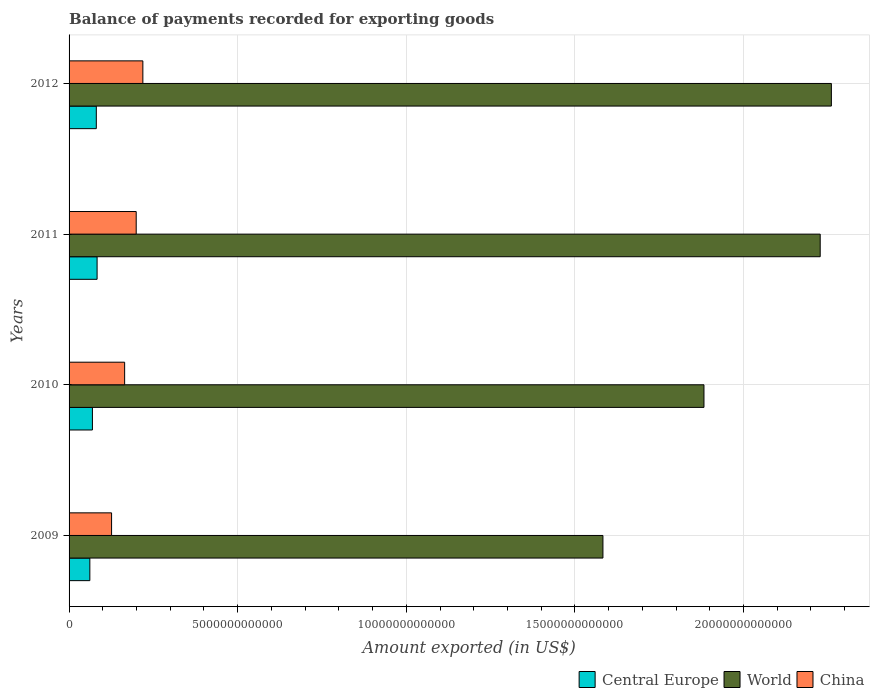Are the number of bars on each tick of the Y-axis equal?
Your response must be concise. Yes. What is the amount exported in Central Europe in 2012?
Provide a short and direct response. 8.08e+11. Across all years, what is the maximum amount exported in Central Europe?
Offer a terse response. 8.31e+11. Across all years, what is the minimum amount exported in China?
Give a very brief answer. 1.26e+12. In which year was the amount exported in Central Europe minimum?
Your response must be concise. 2009. What is the total amount exported in Central Europe in the graph?
Make the answer very short. 2.95e+12. What is the difference between the amount exported in Central Europe in 2010 and that in 2012?
Offer a very short reply. -1.15e+11. What is the difference between the amount exported in World in 2010 and the amount exported in Central Europe in 2009?
Make the answer very short. 1.82e+13. What is the average amount exported in China per year?
Keep it short and to the point. 1.77e+12. In the year 2009, what is the difference between the amount exported in China and amount exported in World?
Your response must be concise. -1.46e+13. In how many years, is the amount exported in Central Europe greater than 9000000000000 US$?
Your answer should be very brief. 0. What is the ratio of the amount exported in World in 2010 to that in 2011?
Provide a succinct answer. 0.85. Is the amount exported in Central Europe in 2011 less than that in 2012?
Provide a succinct answer. No. What is the difference between the highest and the second highest amount exported in Central Europe?
Ensure brevity in your answer.  2.29e+1. What is the difference between the highest and the lowest amount exported in World?
Keep it short and to the point. 6.77e+12. What does the 3rd bar from the top in 2009 represents?
Your answer should be compact. Central Europe. What does the 1st bar from the bottom in 2012 represents?
Make the answer very short. Central Europe. Are all the bars in the graph horizontal?
Your answer should be very brief. Yes. How many years are there in the graph?
Keep it short and to the point. 4. What is the difference between two consecutive major ticks on the X-axis?
Offer a terse response. 5.00e+12. Does the graph contain any zero values?
Your answer should be very brief. No. Where does the legend appear in the graph?
Give a very brief answer. Bottom right. What is the title of the graph?
Offer a terse response. Balance of payments recorded for exporting goods. Does "Kyrgyz Republic" appear as one of the legend labels in the graph?
Your answer should be very brief. No. What is the label or title of the X-axis?
Your response must be concise. Amount exported (in US$). What is the label or title of the Y-axis?
Give a very brief answer. Years. What is the Amount exported (in US$) in Central Europe in 2009?
Your response must be concise. 6.16e+11. What is the Amount exported (in US$) in World in 2009?
Your response must be concise. 1.58e+13. What is the Amount exported (in US$) of China in 2009?
Provide a short and direct response. 1.26e+12. What is the Amount exported (in US$) of Central Europe in 2010?
Ensure brevity in your answer.  6.92e+11. What is the Amount exported (in US$) of World in 2010?
Offer a terse response. 1.88e+13. What is the Amount exported (in US$) of China in 2010?
Keep it short and to the point. 1.65e+12. What is the Amount exported (in US$) in Central Europe in 2011?
Keep it short and to the point. 8.31e+11. What is the Amount exported (in US$) in World in 2011?
Your answer should be very brief. 2.23e+13. What is the Amount exported (in US$) in China in 2011?
Offer a terse response. 1.99e+12. What is the Amount exported (in US$) of Central Europe in 2012?
Provide a succinct answer. 8.08e+11. What is the Amount exported (in US$) of World in 2012?
Your response must be concise. 2.26e+13. What is the Amount exported (in US$) of China in 2012?
Offer a very short reply. 2.19e+12. Across all years, what is the maximum Amount exported (in US$) of Central Europe?
Give a very brief answer. 8.31e+11. Across all years, what is the maximum Amount exported (in US$) of World?
Provide a succinct answer. 2.26e+13. Across all years, what is the maximum Amount exported (in US$) of China?
Provide a succinct answer. 2.19e+12. Across all years, what is the minimum Amount exported (in US$) of Central Europe?
Provide a succinct answer. 6.16e+11. Across all years, what is the minimum Amount exported (in US$) in World?
Give a very brief answer. 1.58e+13. Across all years, what is the minimum Amount exported (in US$) in China?
Ensure brevity in your answer.  1.26e+12. What is the total Amount exported (in US$) in Central Europe in the graph?
Ensure brevity in your answer.  2.95e+12. What is the total Amount exported (in US$) in World in the graph?
Your response must be concise. 7.95e+13. What is the total Amount exported (in US$) of China in the graph?
Your response must be concise. 7.09e+12. What is the difference between the Amount exported (in US$) of Central Europe in 2009 and that in 2010?
Provide a short and direct response. -7.64e+1. What is the difference between the Amount exported (in US$) in World in 2009 and that in 2010?
Provide a succinct answer. -3.00e+12. What is the difference between the Amount exported (in US$) in China in 2009 and that in 2010?
Your answer should be very brief. -3.87e+11. What is the difference between the Amount exported (in US$) in Central Europe in 2009 and that in 2011?
Provide a short and direct response. -2.15e+11. What is the difference between the Amount exported (in US$) in World in 2009 and that in 2011?
Offer a terse response. -6.44e+12. What is the difference between the Amount exported (in US$) in China in 2009 and that in 2011?
Your answer should be compact. -7.30e+11. What is the difference between the Amount exported (in US$) in Central Europe in 2009 and that in 2012?
Give a very brief answer. -1.92e+11. What is the difference between the Amount exported (in US$) in World in 2009 and that in 2012?
Offer a very short reply. -6.77e+12. What is the difference between the Amount exported (in US$) in China in 2009 and that in 2012?
Ensure brevity in your answer.  -9.28e+11. What is the difference between the Amount exported (in US$) in Central Europe in 2010 and that in 2011?
Your response must be concise. -1.38e+11. What is the difference between the Amount exported (in US$) in World in 2010 and that in 2011?
Your answer should be very brief. -3.45e+12. What is the difference between the Amount exported (in US$) of China in 2010 and that in 2011?
Your answer should be very brief. -3.43e+11. What is the difference between the Amount exported (in US$) of Central Europe in 2010 and that in 2012?
Give a very brief answer. -1.15e+11. What is the difference between the Amount exported (in US$) in World in 2010 and that in 2012?
Your answer should be compact. -3.78e+12. What is the difference between the Amount exported (in US$) of China in 2010 and that in 2012?
Provide a succinct answer. -5.41e+11. What is the difference between the Amount exported (in US$) in Central Europe in 2011 and that in 2012?
Provide a succinct answer. 2.29e+1. What is the difference between the Amount exported (in US$) in World in 2011 and that in 2012?
Give a very brief answer. -3.31e+11. What is the difference between the Amount exported (in US$) of China in 2011 and that in 2012?
Your response must be concise. -1.98e+11. What is the difference between the Amount exported (in US$) in Central Europe in 2009 and the Amount exported (in US$) in World in 2010?
Offer a very short reply. -1.82e+13. What is the difference between the Amount exported (in US$) of Central Europe in 2009 and the Amount exported (in US$) of China in 2010?
Your answer should be compact. -1.03e+12. What is the difference between the Amount exported (in US$) of World in 2009 and the Amount exported (in US$) of China in 2010?
Keep it short and to the point. 1.42e+13. What is the difference between the Amount exported (in US$) of Central Europe in 2009 and the Amount exported (in US$) of World in 2011?
Your answer should be compact. -2.17e+13. What is the difference between the Amount exported (in US$) of Central Europe in 2009 and the Amount exported (in US$) of China in 2011?
Provide a succinct answer. -1.37e+12. What is the difference between the Amount exported (in US$) in World in 2009 and the Amount exported (in US$) in China in 2011?
Keep it short and to the point. 1.38e+13. What is the difference between the Amount exported (in US$) of Central Europe in 2009 and the Amount exported (in US$) of World in 2012?
Make the answer very short. -2.20e+13. What is the difference between the Amount exported (in US$) of Central Europe in 2009 and the Amount exported (in US$) of China in 2012?
Make the answer very short. -1.57e+12. What is the difference between the Amount exported (in US$) in World in 2009 and the Amount exported (in US$) in China in 2012?
Your answer should be compact. 1.36e+13. What is the difference between the Amount exported (in US$) in Central Europe in 2010 and the Amount exported (in US$) in World in 2011?
Ensure brevity in your answer.  -2.16e+13. What is the difference between the Amount exported (in US$) of Central Europe in 2010 and the Amount exported (in US$) of China in 2011?
Offer a very short reply. -1.30e+12. What is the difference between the Amount exported (in US$) of World in 2010 and the Amount exported (in US$) of China in 2011?
Your answer should be compact. 1.68e+13. What is the difference between the Amount exported (in US$) of Central Europe in 2010 and the Amount exported (in US$) of World in 2012?
Give a very brief answer. -2.19e+13. What is the difference between the Amount exported (in US$) of Central Europe in 2010 and the Amount exported (in US$) of China in 2012?
Offer a very short reply. -1.50e+12. What is the difference between the Amount exported (in US$) in World in 2010 and the Amount exported (in US$) in China in 2012?
Keep it short and to the point. 1.66e+13. What is the difference between the Amount exported (in US$) in Central Europe in 2011 and the Amount exported (in US$) in World in 2012?
Ensure brevity in your answer.  -2.18e+13. What is the difference between the Amount exported (in US$) of Central Europe in 2011 and the Amount exported (in US$) of China in 2012?
Provide a succinct answer. -1.36e+12. What is the difference between the Amount exported (in US$) in World in 2011 and the Amount exported (in US$) in China in 2012?
Make the answer very short. 2.01e+13. What is the average Amount exported (in US$) of Central Europe per year?
Your answer should be very brief. 7.37e+11. What is the average Amount exported (in US$) of World per year?
Ensure brevity in your answer.  1.99e+13. What is the average Amount exported (in US$) in China per year?
Offer a terse response. 1.77e+12. In the year 2009, what is the difference between the Amount exported (in US$) in Central Europe and Amount exported (in US$) in World?
Offer a very short reply. -1.52e+13. In the year 2009, what is the difference between the Amount exported (in US$) of Central Europe and Amount exported (in US$) of China?
Your answer should be compact. -6.44e+11. In the year 2009, what is the difference between the Amount exported (in US$) of World and Amount exported (in US$) of China?
Offer a very short reply. 1.46e+13. In the year 2010, what is the difference between the Amount exported (in US$) of Central Europe and Amount exported (in US$) of World?
Provide a succinct answer. -1.81e+13. In the year 2010, what is the difference between the Amount exported (in US$) of Central Europe and Amount exported (in US$) of China?
Keep it short and to the point. -9.55e+11. In the year 2010, what is the difference between the Amount exported (in US$) in World and Amount exported (in US$) in China?
Make the answer very short. 1.72e+13. In the year 2011, what is the difference between the Amount exported (in US$) in Central Europe and Amount exported (in US$) in World?
Offer a terse response. -2.14e+13. In the year 2011, what is the difference between the Amount exported (in US$) of Central Europe and Amount exported (in US$) of China?
Make the answer very short. -1.16e+12. In the year 2011, what is the difference between the Amount exported (in US$) in World and Amount exported (in US$) in China?
Your answer should be very brief. 2.03e+13. In the year 2012, what is the difference between the Amount exported (in US$) in Central Europe and Amount exported (in US$) in World?
Offer a terse response. -2.18e+13. In the year 2012, what is the difference between the Amount exported (in US$) in Central Europe and Amount exported (in US$) in China?
Give a very brief answer. -1.38e+12. In the year 2012, what is the difference between the Amount exported (in US$) of World and Amount exported (in US$) of China?
Your response must be concise. 2.04e+13. What is the ratio of the Amount exported (in US$) of Central Europe in 2009 to that in 2010?
Your answer should be very brief. 0.89. What is the ratio of the Amount exported (in US$) of World in 2009 to that in 2010?
Offer a very short reply. 0.84. What is the ratio of the Amount exported (in US$) of China in 2009 to that in 2010?
Offer a terse response. 0.76. What is the ratio of the Amount exported (in US$) of Central Europe in 2009 to that in 2011?
Provide a succinct answer. 0.74. What is the ratio of the Amount exported (in US$) of World in 2009 to that in 2011?
Your answer should be very brief. 0.71. What is the ratio of the Amount exported (in US$) in China in 2009 to that in 2011?
Your response must be concise. 0.63. What is the ratio of the Amount exported (in US$) in Central Europe in 2009 to that in 2012?
Your answer should be compact. 0.76. What is the ratio of the Amount exported (in US$) in World in 2009 to that in 2012?
Offer a terse response. 0.7. What is the ratio of the Amount exported (in US$) of China in 2009 to that in 2012?
Offer a terse response. 0.58. What is the ratio of the Amount exported (in US$) in Central Europe in 2010 to that in 2011?
Give a very brief answer. 0.83. What is the ratio of the Amount exported (in US$) of World in 2010 to that in 2011?
Your answer should be very brief. 0.85. What is the ratio of the Amount exported (in US$) in China in 2010 to that in 2011?
Ensure brevity in your answer.  0.83. What is the ratio of the Amount exported (in US$) in Central Europe in 2010 to that in 2012?
Your answer should be compact. 0.86. What is the ratio of the Amount exported (in US$) in World in 2010 to that in 2012?
Your answer should be very brief. 0.83. What is the ratio of the Amount exported (in US$) in China in 2010 to that in 2012?
Your answer should be very brief. 0.75. What is the ratio of the Amount exported (in US$) of Central Europe in 2011 to that in 2012?
Ensure brevity in your answer.  1.03. What is the ratio of the Amount exported (in US$) of World in 2011 to that in 2012?
Ensure brevity in your answer.  0.99. What is the ratio of the Amount exported (in US$) of China in 2011 to that in 2012?
Ensure brevity in your answer.  0.91. What is the difference between the highest and the second highest Amount exported (in US$) of Central Europe?
Offer a terse response. 2.29e+1. What is the difference between the highest and the second highest Amount exported (in US$) of World?
Offer a very short reply. 3.31e+11. What is the difference between the highest and the second highest Amount exported (in US$) of China?
Ensure brevity in your answer.  1.98e+11. What is the difference between the highest and the lowest Amount exported (in US$) of Central Europe?
Offer a very short reply. 2.15e+11. What is the difference between the highest and the lowest Amount exported (in US$) of World?
Your answer should be very brief. 6.77e+12. What is the difference between the highest and the lowest Amount exported (in US$) in China?
Ensure brevity in your answer.  9.28e+11. 